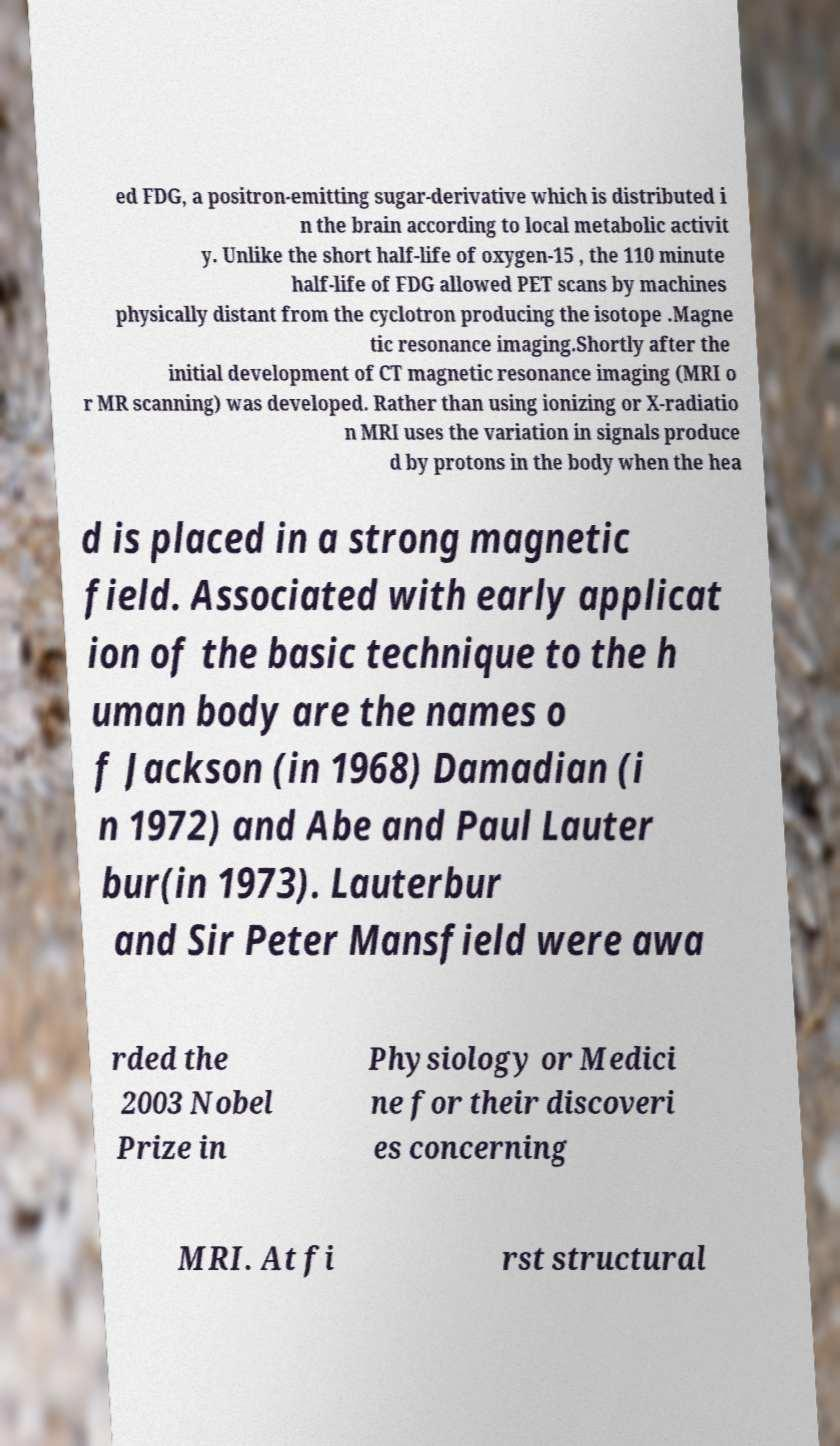What messages or text are displayed in this image? I need them in a readable, typed format. ed FDG, a positron-emitting sugar-derivative which is distributed i n the brain according to local metabolic activit y. Unlike the short half-life of oxygen-15 , the 110 minute half-life of FDG allowed PET scans by machines physically distant from the cyclotron producing the isotope .Magne tic resonance imaging.Shortly after the initial development of CT magnetic resonance imaging (MRI o r MR scanning) was developed. Rather than using ionizing or X-radiatio n MRI uses the variation in signals produce d by protons in the body when the hea d is placed in a strong magnetic field. Associated with early applicat ion of the basic technique to the h uman body are the names o f Jackson (in 1968) Damadian (i n 1972) and Abe and Paul Lauter bur(in 1973). Lauterbur and Sir Peter Mansfield were awa rded the 2003 Nobel Prize in Physiology or Medici ne for their discoveri es concerning MRI. At fi rst structural 